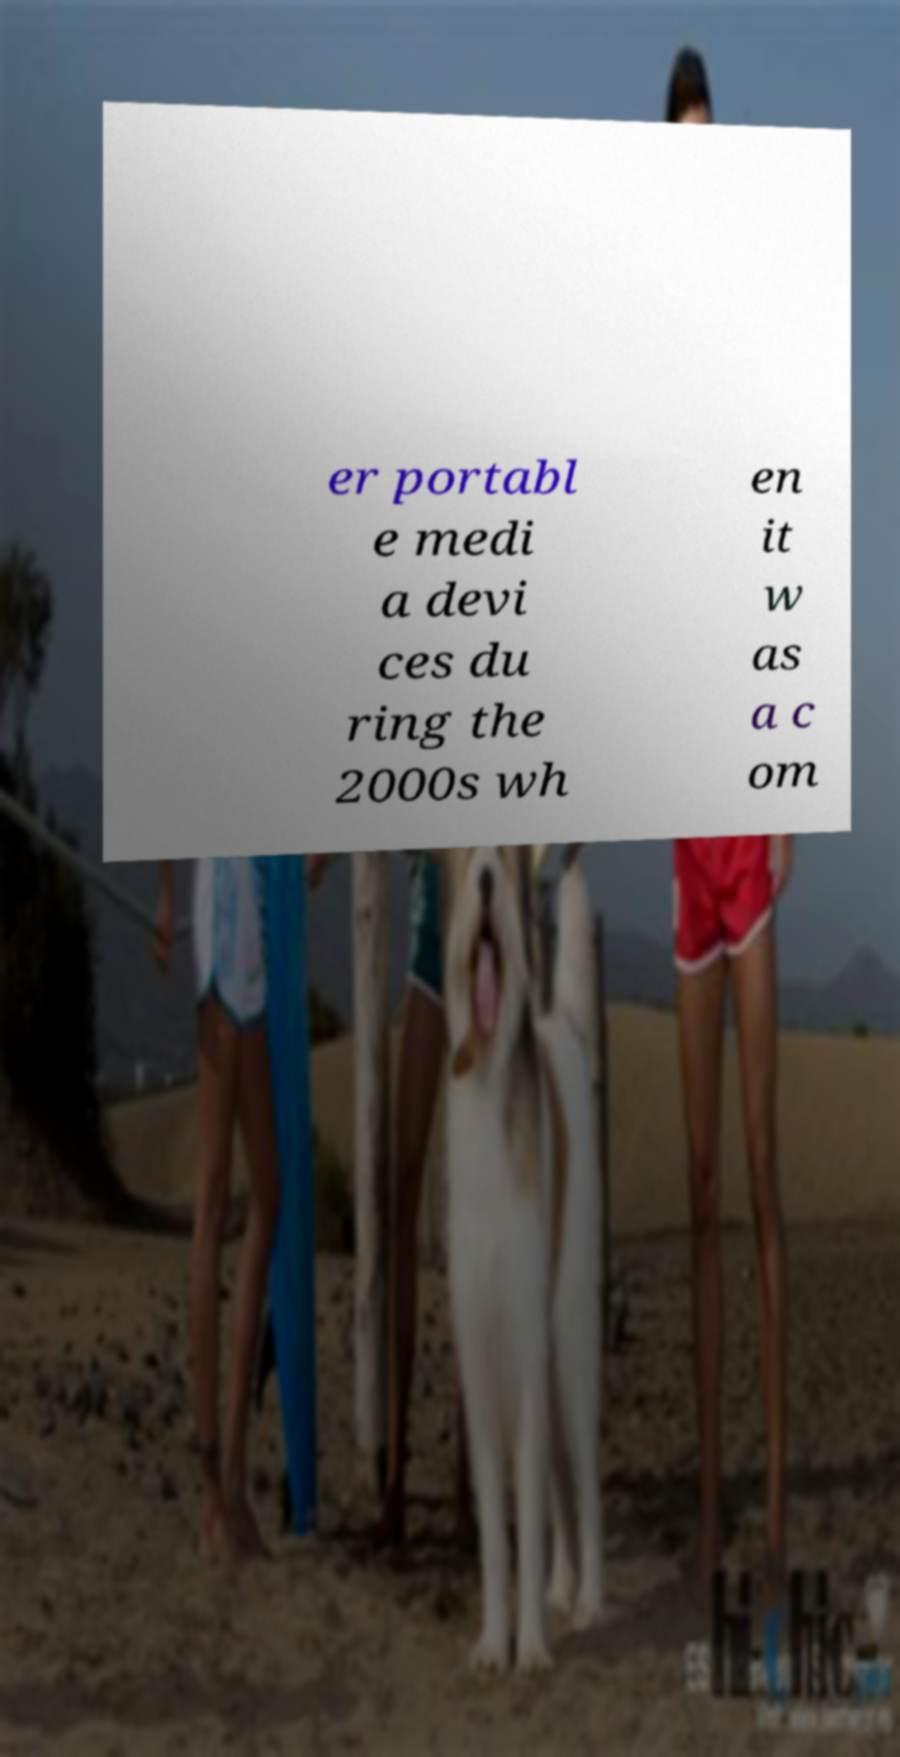Please identify and transcribe the text found in this image. er portabl e medi a devi ces du ring the 2000s wh en it w as a c om 